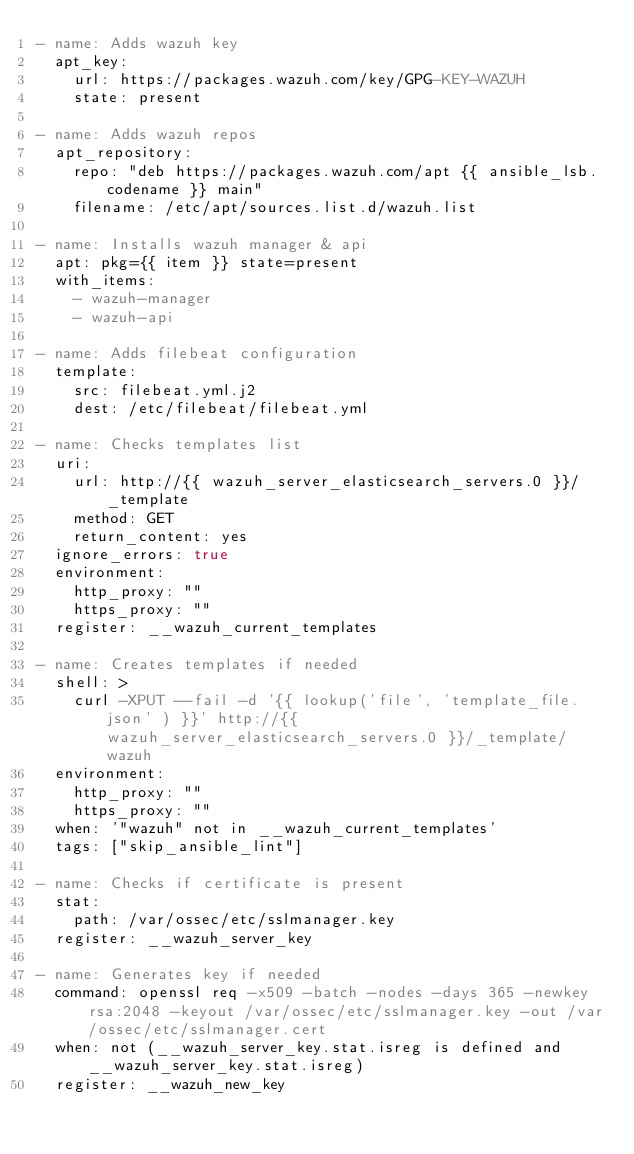Convert code to text. <code><loc_0><loc_0><loc_500><loc_500><_YAML_>- name: Adds wazuh key
  apt_key:
    url: https://packages.wazuh.com/key/GPG-KEY-WAZUH
    state: present

- name: Adds wazuh repos
  apt_repository:
    repo: "deb https://packages.wazuh.com/apt {{ ansible_lsb.codename }} main"
    filename: /etc/apt/sources.list.d/wazuh.list

- name: Installs wazuh manager & api
  apt: pkg={{ item }} state=present
  with_items:
    - wazuh-manager
    - wazuh-api

- name: Adds filebeat configuration
  template:
    src: filebeat.yml.j2
    dest: /etc/filebeat/filebeat.yml

- name: Checks templates list
  uri:
    url: http://{{ wazuh_server_elasticsearch_servers.0 }}/_template
    method: GET
    return_content: yes
  ignore_errors: true
  environment:
    http_proxy: ""
    https_proxy: ""
  register: __wazuh_current_templates

- name: Creates templates if needed
  shell: >
    curl -XPUT --fail -d '{{ lookup('file', 'template_file.json' ) }}' http://{{ wazuh_server_elasticsearch_servers.0 }}/_template/wazuh
  environment:
    http_proxy: ""
    https_proxy: ""
  when: '"wazuh" not in __wazuh_current_templates'
  tags: ["skip_ansible_lint"]

- name: Checks if certificate is present
  stat:
    path: /var/ossec/etc/sslmanager.key
  register: __wazuh_server_key

- name: Generates key if needed
  command: openssl req -x509 -batch -nodes -days 365 -newkey rsa:2048 -keyout /var/ossec/etc/sslmanager.key -out /var/ossec/etc/sslmanager.cert
  when: not (__wazuh_server_key.stat.isreg is defined and __wazuh_server_key.stat.isreg)
  register: __wazuh_new_key



</code> 